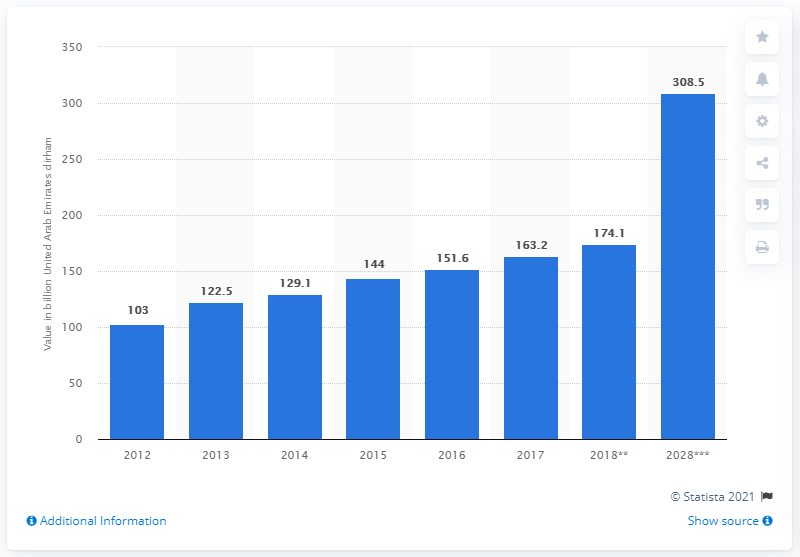Highlight a few significant elements in this photo. According to forecasts, the contribution of internal tourism consumption to the Gross Domestic Product (GDP) of the United Arab Emirates (UAE) is expected to reach 308.5 billion dirhams by 2028. 